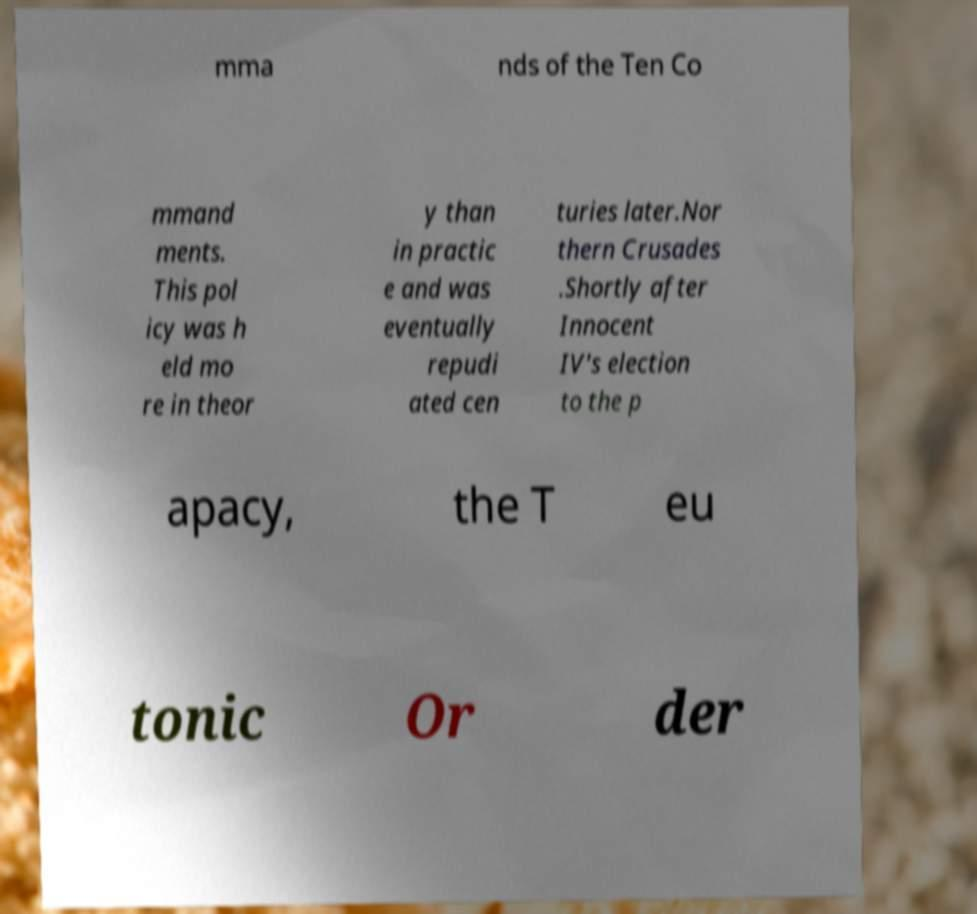Could you assist in decoding the text presented in this image and type it out clearly? mma nds of the Ten Co mmand ments. This pol icy was h eld mo re in theor y than in practic e and was eventually repudi ated cen turies later.Nor thern Crusades .Shortly after Innocent IV's election to the p apacy, the T eu tonic Or der 